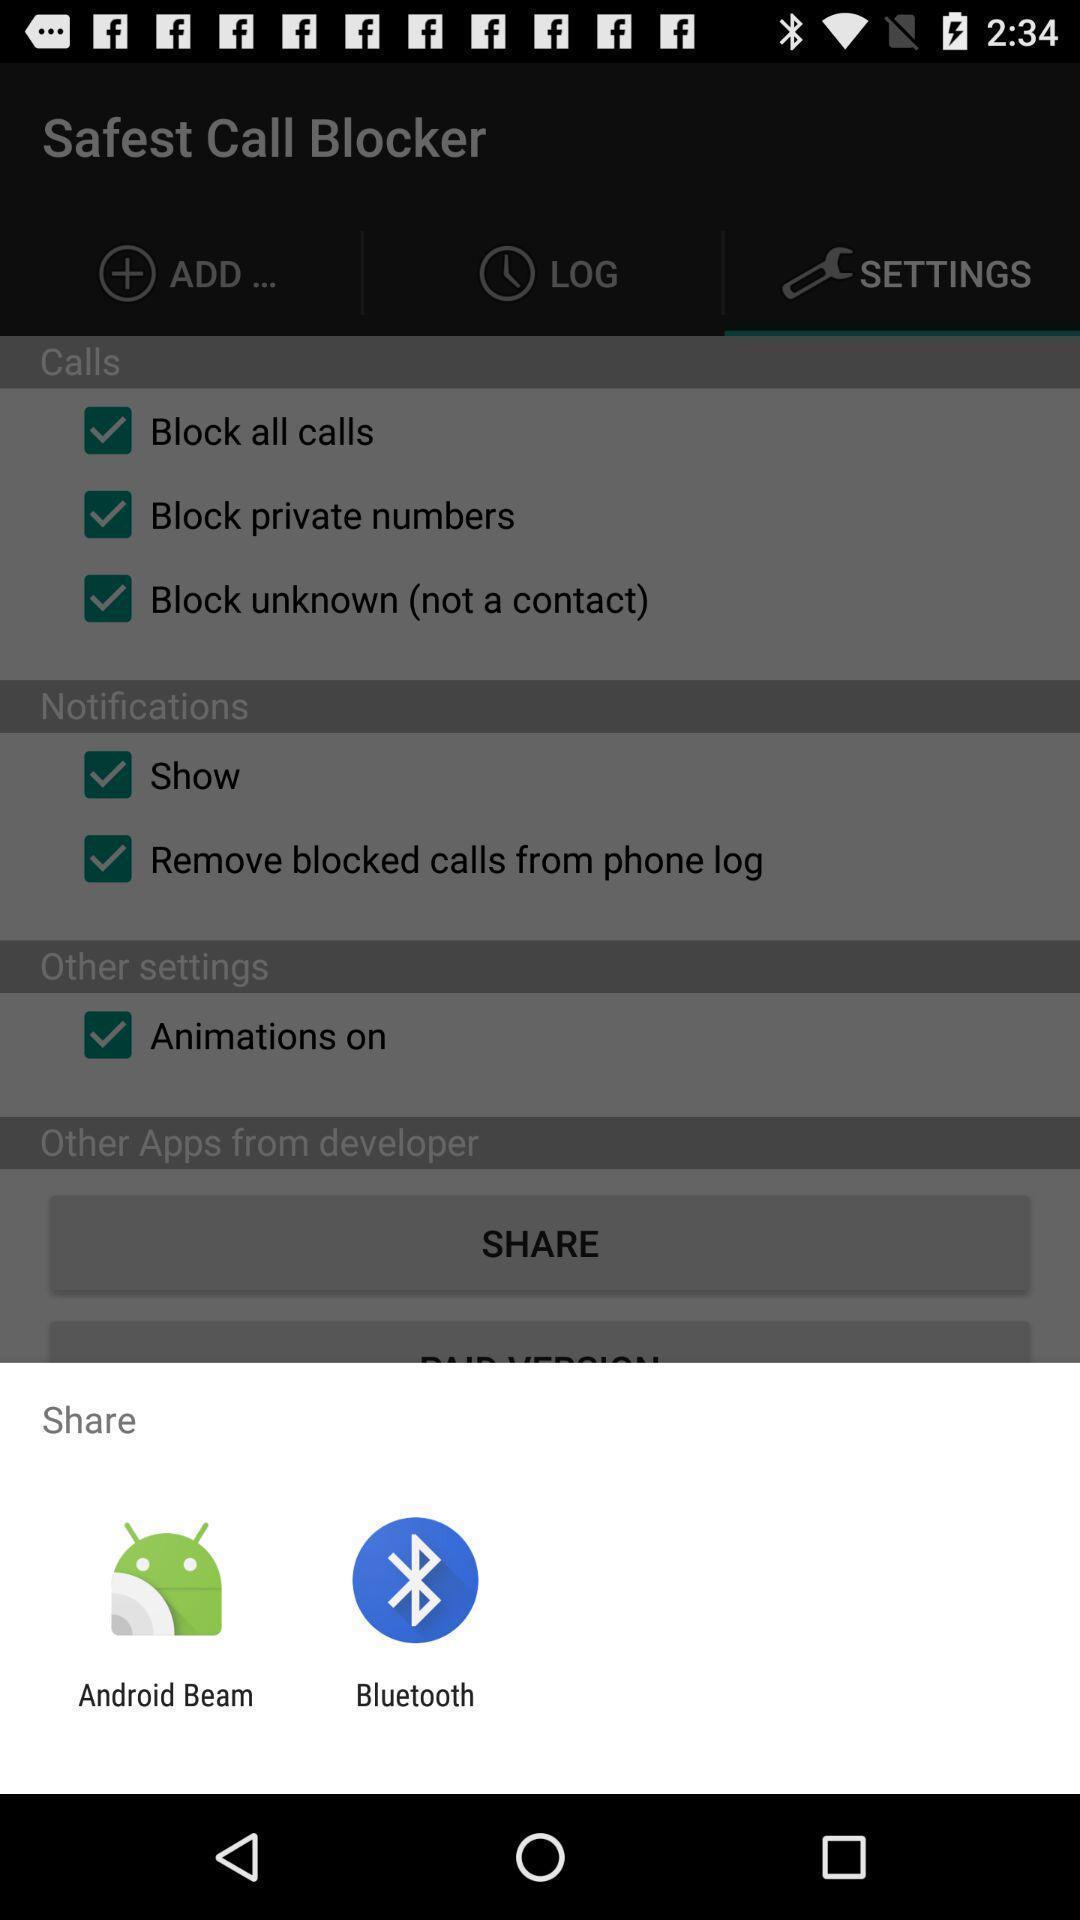Tell me about the visual elements in this screen capture. Share safest call blocker with different app. 